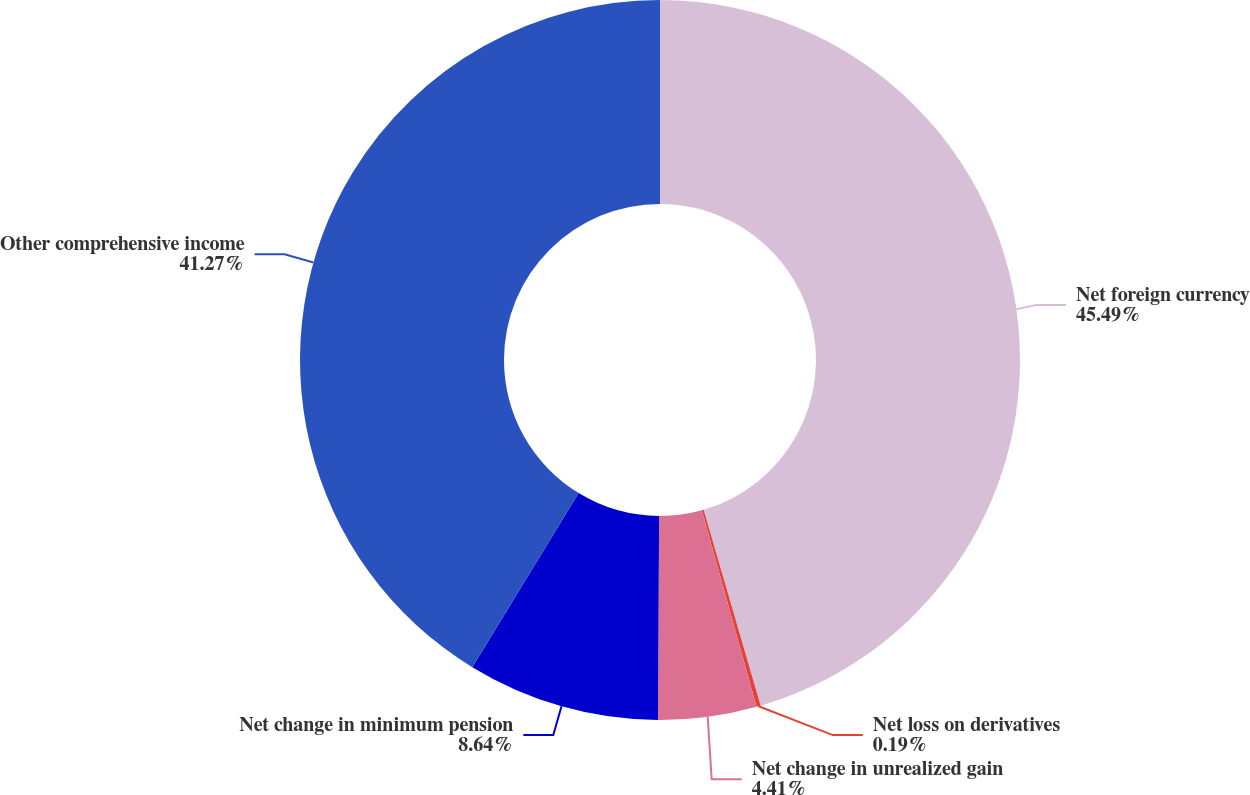<chart> <loc_0><loc_0><loc_500><loc_500><pie_chart><fcel>Net foreign currency<fcel>Net loss on derivatives<fcel>Net change in unrealized gain<fcel>Net change in minimum pension<fcel>Other comprehensive income<nl><fcel>45.49%<fcel>0.19%<fcel>4.41%<fcel>8.64%<fcel>41.27%<nl></chart> 